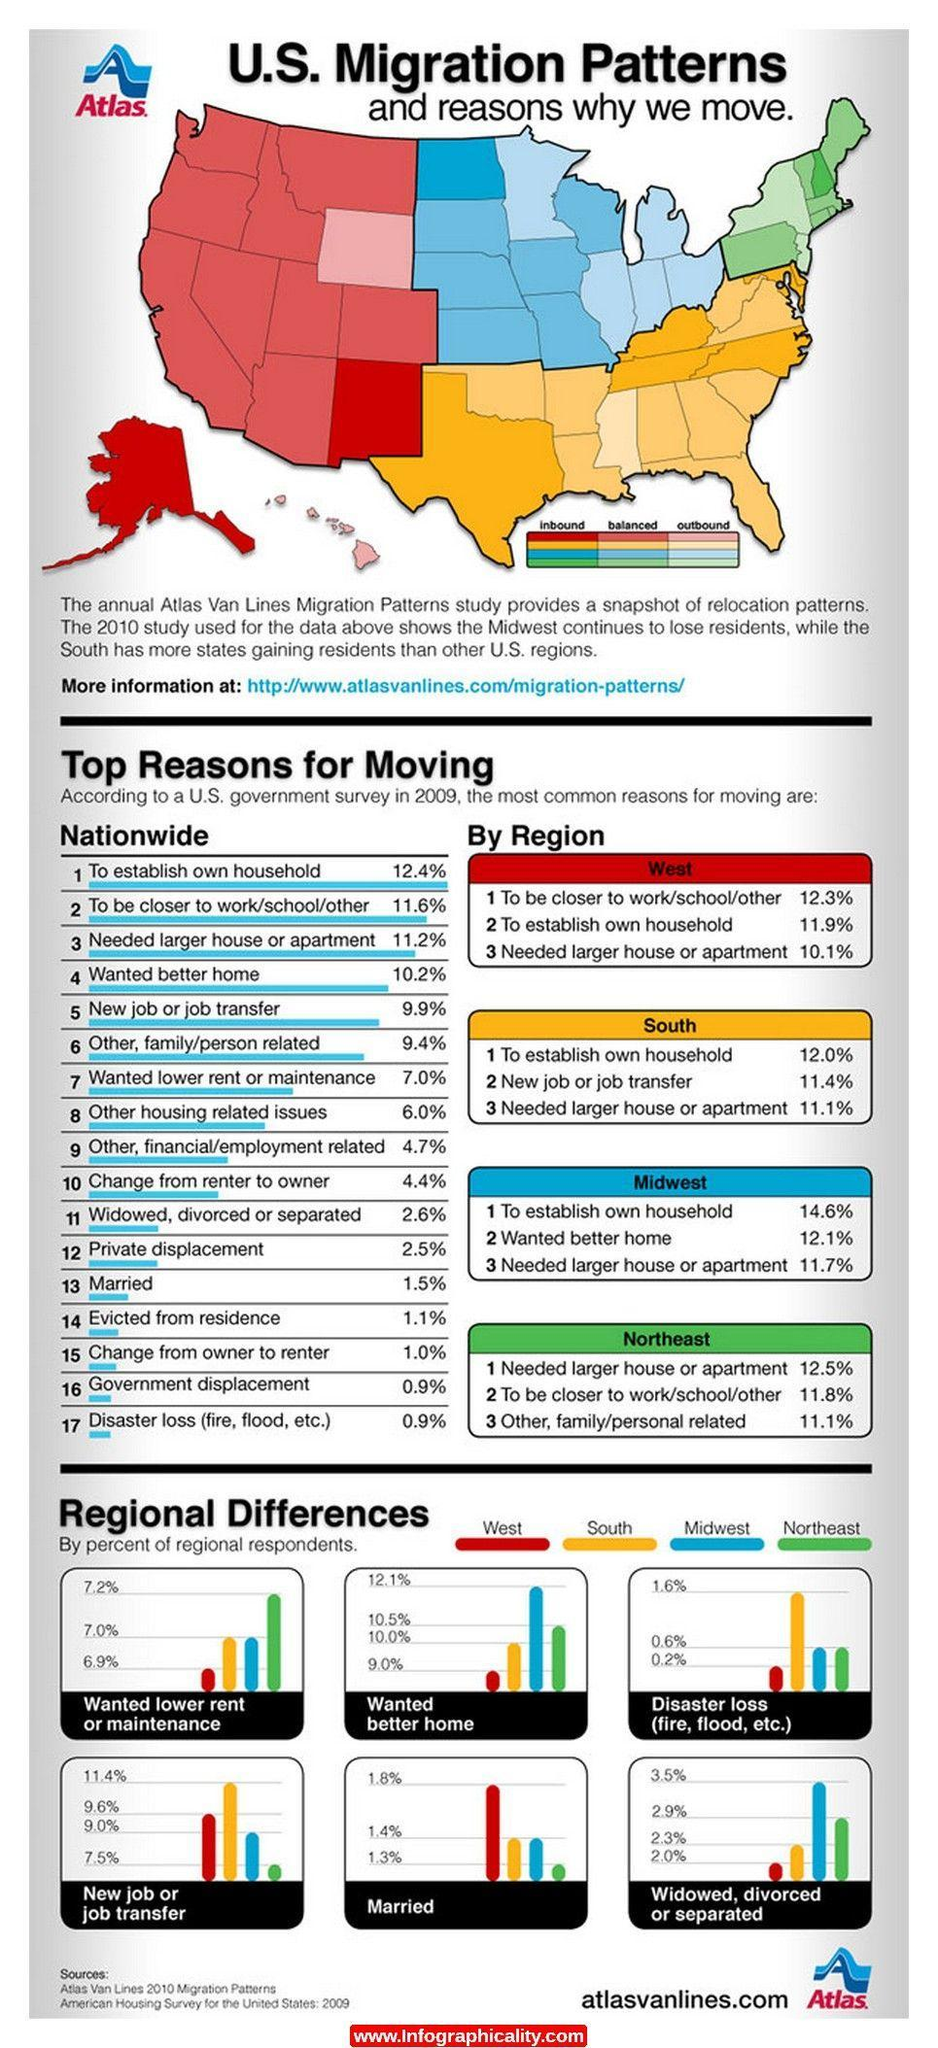Which region had the lowest percentage of moves due to marriage?
Answer the question with a short phrase. North East Identify the state in South region of US that has more outbound population? Missippi Which region had the highest chances of disaster loss? Disaster loss What was the percentage of migration in the South due to job transfers? 11.4% What percentage of people moved due to government displacement or disaster loss? 0.9% What percentage of people in the South and Mid West wanted a lower rent or maintenance? 7.0% What was the common reason in all four regions for people to move, larger house, family, job transfer, or commutation? larger house Which region had a lowest percentage of people moving places for better homes? West Which states in the West has more inbound migration? Alaska, New Mexico Which  state in the North East region that has outbound migration? New York, New Jersey 